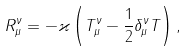<formula> <loc_0><loc_0><loc_500><loc_500>R _ { \mu } ^ { \nu } = - \varkappa \left ( T _ { \mu } ^ { \nu } - \frac { 1 } { 2 } \delta _ { \mu } ^ { \nu } T \right ) ,</formula> 